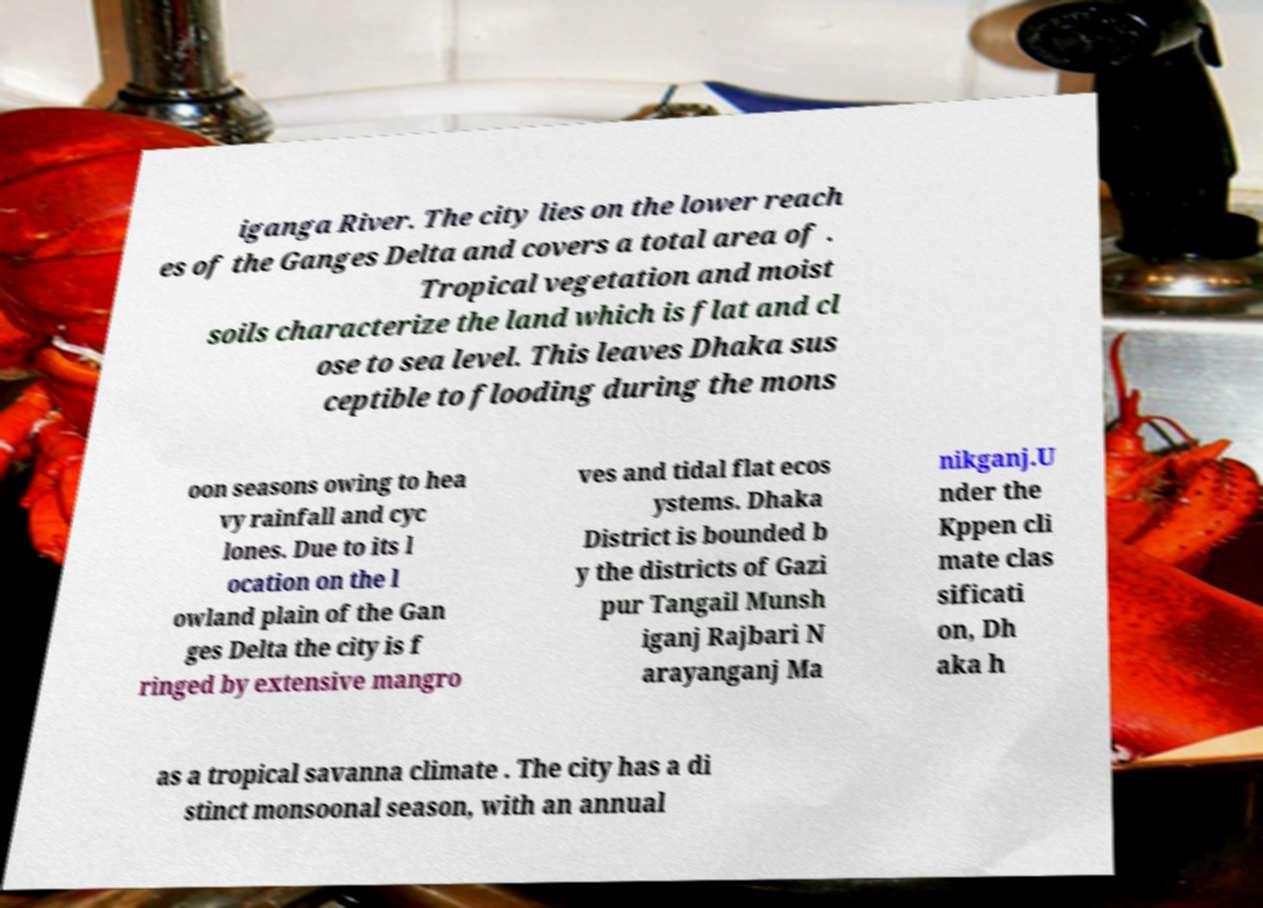I need the written content from this picture converted into text. Can you do that? iganga River. The city lies on the lower reach es of the Ganges Delta and covers a total area of . Tropical vegetation and moist soils characterize the land which is flat and cl ose to sea level. This leaves Dhaka sus ceptible to flooding during the mons oon seasons owing to hea vy rainfall and cyc lones. Due to its l ocation on the l owland plain of the Gan ges Delta the city is f ringed by extensive mangro ves and tidal flat ecos ystems. Dhaka District is bounded b y the districts of Gazi pur Tangail Munsh iganj Rajbari N arayanganj Ma nikganj.U nder the Kppen cli mate clas sificati on, Dh aka h as a tropical savanna climate . The city has a di stinct monsoonal season, with an annual 